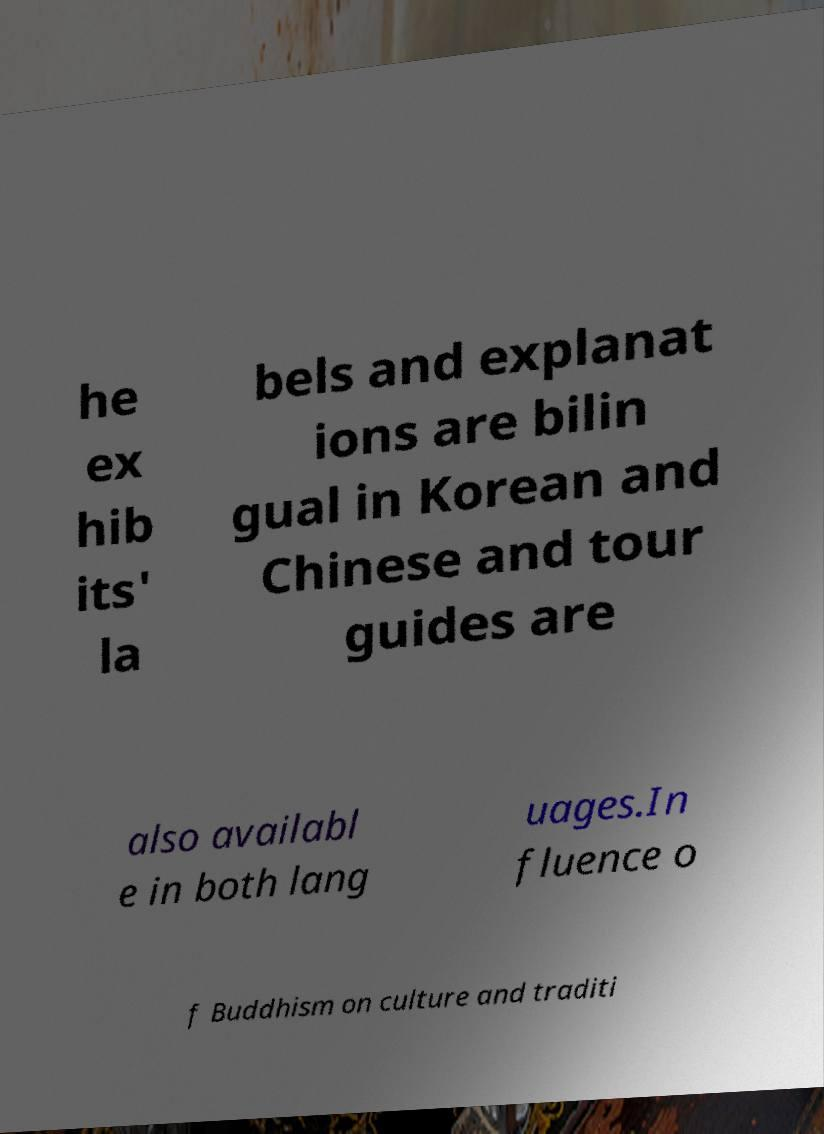Please identify and transcribe the text found in this image. he ex hib its' la bels and explanat ions are bilin gual in Korean and Chinese and tour guides are also availabl e in both lang uages.In fluence o f Buddhism on culture and traditi 